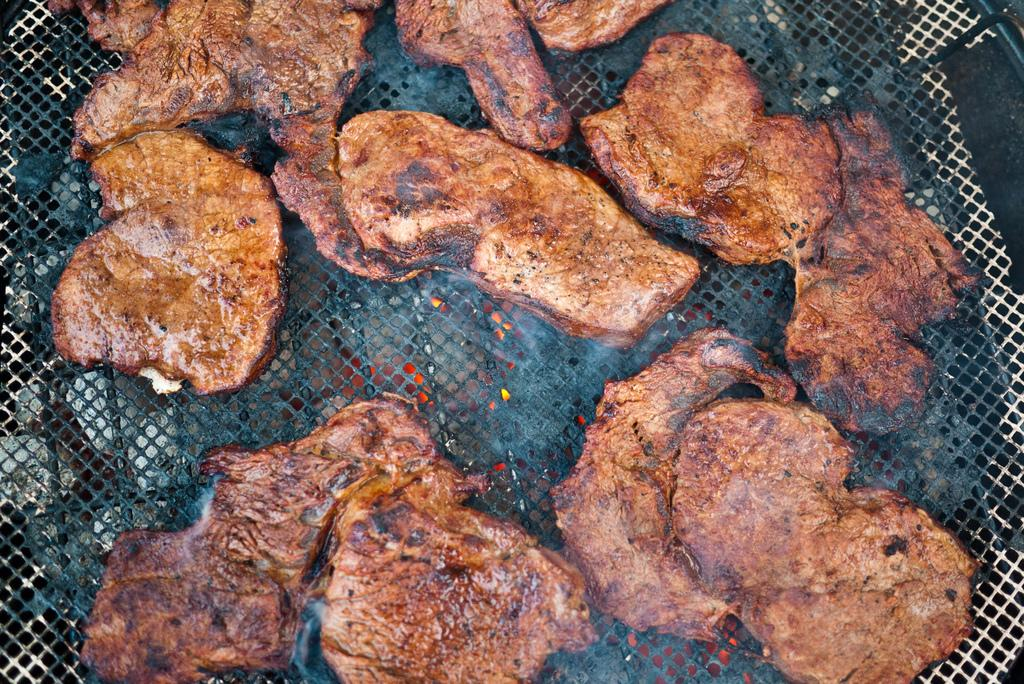What is being cooked in the image? There is meat being grilled in the image. How is the meat being cooked? The meat is on a mesh, and there is fire under the mesh. What type of town can be seen in the background of the image? There is no town visible in the image; it only shows meat being grilled on a mesh with fire underneath. 